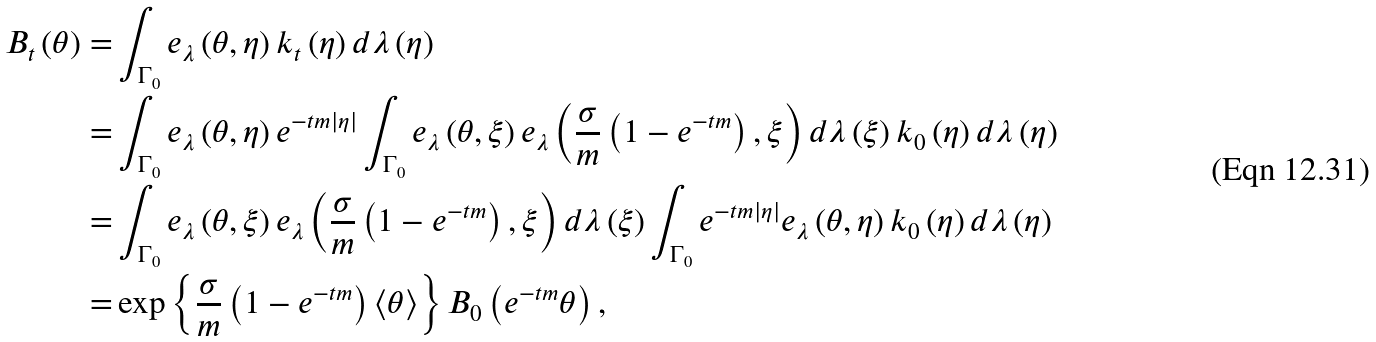<formula> <loc_0><loc_0><loc_500><loc_500>B _ { t } \left ( \theta \right ) = & \int _ { \Gamma _ { 0 } } e _ { \lambda } \left ( \theta , \eta \right ) k _ { t } \left ( \eta \right ) d \lambda \left ( \eta \right ) \\ = & \int _ { \Gamma _ { 0 } } e _ { \lambda } \left ( \theta , \eta \right ) e ^ { - t m \left | \eta \right | } \int _ { \Gamma _ { 0 } } e _ { \lambda } \left ( \theta , \xi \right ) e _ { \lambda } \left ( \frac { \sigma } { m } \left ( 1 - e ^ { - t m } \right ) , \xi \right ) d \lambda \left ( \xi \right ) k _ { 0 } \left ( \eta \right ) d \lambda \left ( \eta \right ) \\ = & \int _ { \Gamma _ { 0 } } e _ { \lambda } \left ( \theta , \xi \right ) e _ { \lambda } \left ( \frac { \sigma } { m } \left ( 1 - e ^ { - t m } \right ) , \xi \right ) d \lambda \left ( \xi \right ) \int _ { \Gamma _ { 0 } } e ^ { - t m \left | \eta \right | } e _ { \lambda } \left ( \theta , \eta \right ) k _ { 0 } \left ( \eta \right ) d \lambda \left ( \eta \right ) \\ = & \exp \left \{ \frac { \sigma } { m } \left ( 1 - e ^ { - t m } \right ) \left \langle \theta \right \rangle \right \} B _ { 0 } \left ( e ^ { - t m } \theta \right ) ,</formula> 